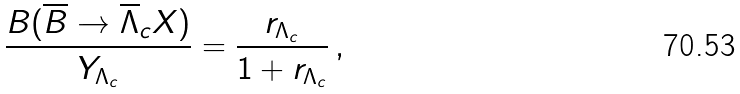<formula> <loc_0><loc_0><loc_500><loc_500>\frac { B ( \overline { B } \rightarrow \overline { \Lambda } _ { c } X ) } { Y _ { \Lambda _ { c } } } = \frac { r _ { \Lambda _ { c } } } { 1 + r _ { \Lambda _ { c } } } \, ,</formula> 